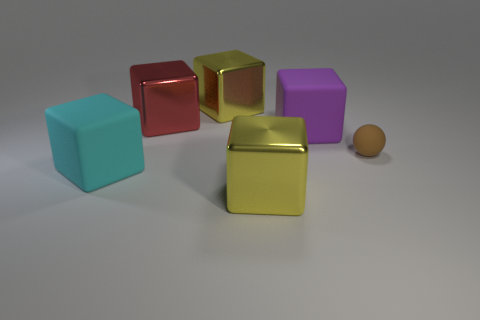Subtract all purple cubes. How many cubes are left? 4 Subtract all big cyan matte cubes. How many cubes are left? 4 Subtract 2 blocks. How many blocks are left? 3 Subtract all red blocks. Subtract all blue cylinders. How many blocks are left? 4 Add 1 cyan matte cubes. How many objects exist? 7 Subtract all spheres. How many objects are left? 5 Subtract 1 brown balls. How many objects are left? 5 Subtract all shiny blocks. Subtract all large cyan matte things. How many objects are left? 2 Add 6 large red shiny blocks. How many large red shiny blocks are left? 7 Add 4 big blue metal cylinders. How many big blue metal cylinders exist? 4 